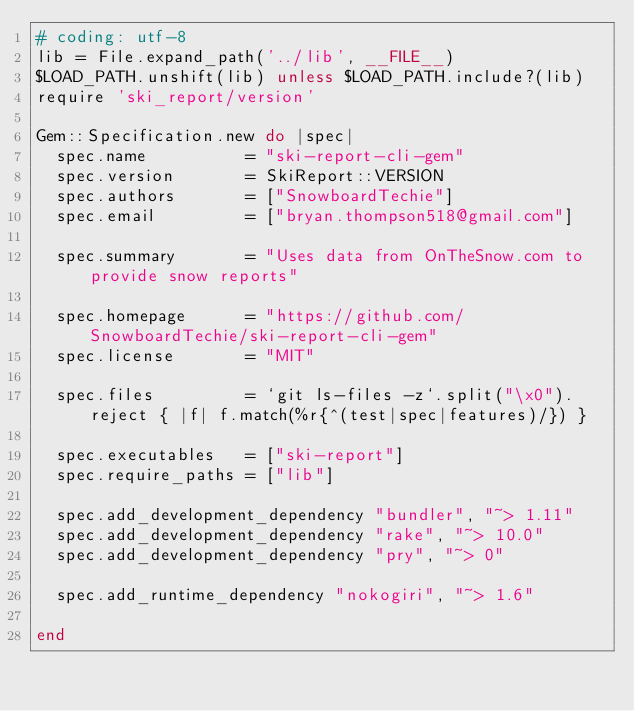<code> <loc_0><loc_0><loc_500><loc_500><_Ruby_># coding: utf-8
lib = File.expand_path('../lib', __FILE__)
$LOAD_PATH.unshift(lib) unless $LOAD_PATH.include?(lib)
require 'ski_report/version'

Gem::Specification.new do |spec|
  spec.name          = "ski-report-cli-gem"
  spec.version       = SkiReport::VERSION
  spec.authors       = ["SnowboardTechie"]
  spec.email         = ["bryan.thompson518@gmail.com"]

  spec.summary       = "Uses data from OnTheSnow.com to provide snow reports"
  
  spec.homepage      = "https://github.com/SnowboardTechie/ski-report-cli-gem"
  spec.license       = "MIT"

  spec.files         = `git ls-files -z`.split("\x0").reject { |f| f.match(%r{^(test|spec|features)/}) }
  
  spec.executables   = ["ski-report"]
  spec.require_paths = ["lib"]

  spec.add_development_dependency "bundler", "~> 1.11"
  spec.add_development_dependency "rake", "~> 10.0"
  spec.add_development_dependency "pry", "~> 0"

  spec.add_runtime_dependency "nokogiri", "~> 1.6"
  
end
</code> 